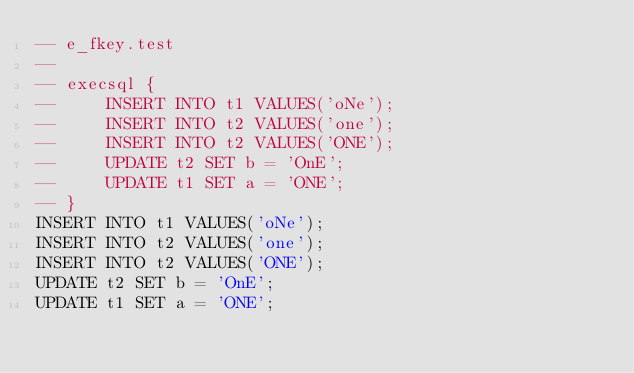<code> <loc_0><loc_0><loc_500><loc_500><_SQL_>-- e_fkey.test
-- 
-- execsql {
--     INSERT INTO t1 VALUES('oNe');
--     INSERT INTO t2 VALUES('one');
--     INSERT INTO t2 VALUES('ONE');
--     UPDATE t2 SET b = 'OnE';
--     UPDATE t1 SET a = 'ONE';
-- }
INSERT INTO t1 VALUES('oNe');
INSERT INTO t2 VALUES('one');
INSERT INTO t2 VALUES('ONE');
UPDATE t2 SET b = 'OnE';
UPDATE t1 SET a = 'ONE';</code> 